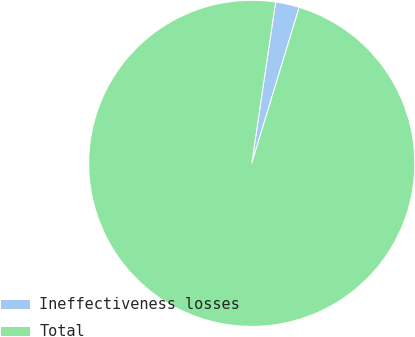Convert chart to OTSL. <chart><loc_0><loc_0><loc_500><loc_500><pie_chart><fcel>Ineffectiveness losses<fcel>Total<nl><fcel>2.36%<fcel>97.64%<nl></chart> 